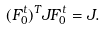Convert formula to latex. <formula><loc_0><loc_0><loc_500><loc_500>( F _ { 0 } ^ { t } ) ^ { T } J F _ { 0 } ^ { t } = J .</formula> 